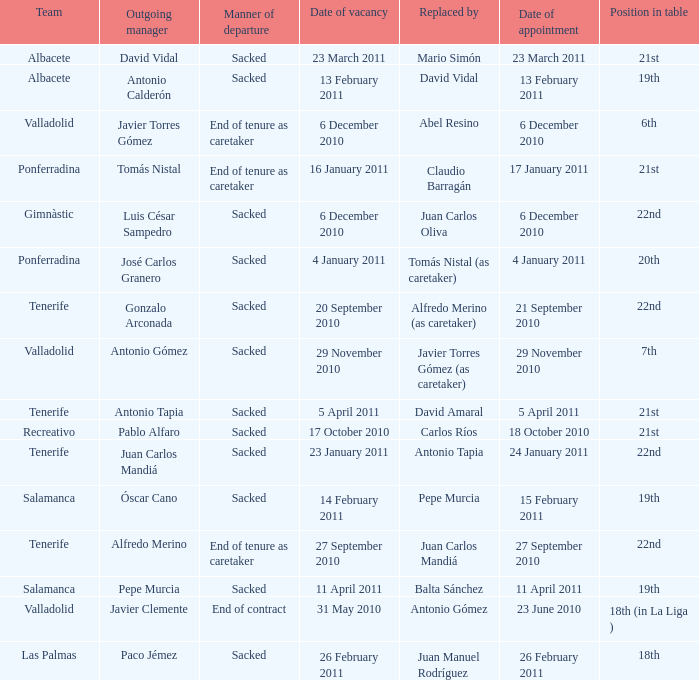Parse the table in full. {'header': ['Team', 'Outgoing manager', 'Manner of departure', 'Date of vacancy', 'Replaced by', 'Date of appointment', 'Position in table'], 'rows': [['Albacete', 'David Vidal', 'Sacked', '23 March 2011', 'Mario Simón', '23 March 2011', '21st'], ['Albacete', 'Antonio Calderón', 'Sacked', '13 February 2011', 'David Vidal', '13 February 2011', '19th'], ['Valladolid', 'Javier Torres Gómez', 'End of tenure as caretaker', '6 December 2010', 'Abel Resino', '6 December 2010', '6th'], ['Ponferradina', 'Tomás Nistal', 'End of tenure as caretaker', '16 January 2011', 'Claudio Barragán', '17 January 2011', '21st'], ['Gimnàstic', 'Luis César Sampedro', 'Sacked', '6 December 2010', 'Juan Carlos Oliva', '6 December 2010', '22nd'], ['Ponferradina', 'José Carlos Granero', 'Sacked', '4 January 2011', 'Tomás Nistal (as caretaker)', '4 January 2011', '20th'], ['Tenerife', 'Gonzalo Arconada', 'Sacked', '20 September 2010', 'Alfredo Merino (as caretaker)', '21 September 2010', '22nd'], ['Valladolid', 'Antonio Gómez', 'Sacked', '29 November 2010', 'Javier Torres Gómez (as caretaker)', '29 November 2010', '7th'], ['Tenerife', 'Antonio Tapia', 'Sacked', '5 April 2011', 'David Amaral', '5 April 2011', '21st'], ['Recreativo', 'Pablo Alfaro', 'Sacked', '17 October 2010', 'Carlos Ríos', '18 October 2010', '21st'], ['Tenerife', 'Juan Carlos Mandiá', 'Sacked', '23 January 2011', 'Antonio Tapia', '24 January 2011', '22nd'], ['Salamanca', 'Óscar Cano', 'Sacked', '14 February 2011', 'Pepe Murcia', '15 February 2011', '19th'], ['Tenerife', 'Alfredo Merino', 'End of tenure as caretaker', '27 September 2010', 'Juan Carlos Mandiá', '27 September 2010', '22nd'], ['Salamanca', 'Pepe Murcia', 'Sacked', '11 April 2011', 'Balta Sánchez', '11 April 2011', '19th'], ['Valladolid', 'Javier Clemente', 'End of contract', '31 May 2010', 'Antonio Gómez', '23 June 2010', '18th (in La Liga )'], ['Las Palmas', 'Paco Jémez', 'Sacked', '26 February 2011', 'Juan Manuel Rodríguez', '26 February 2011', '18th']]} What was the manner of departure for the appointment date of 21 september 2010 Sacked. 